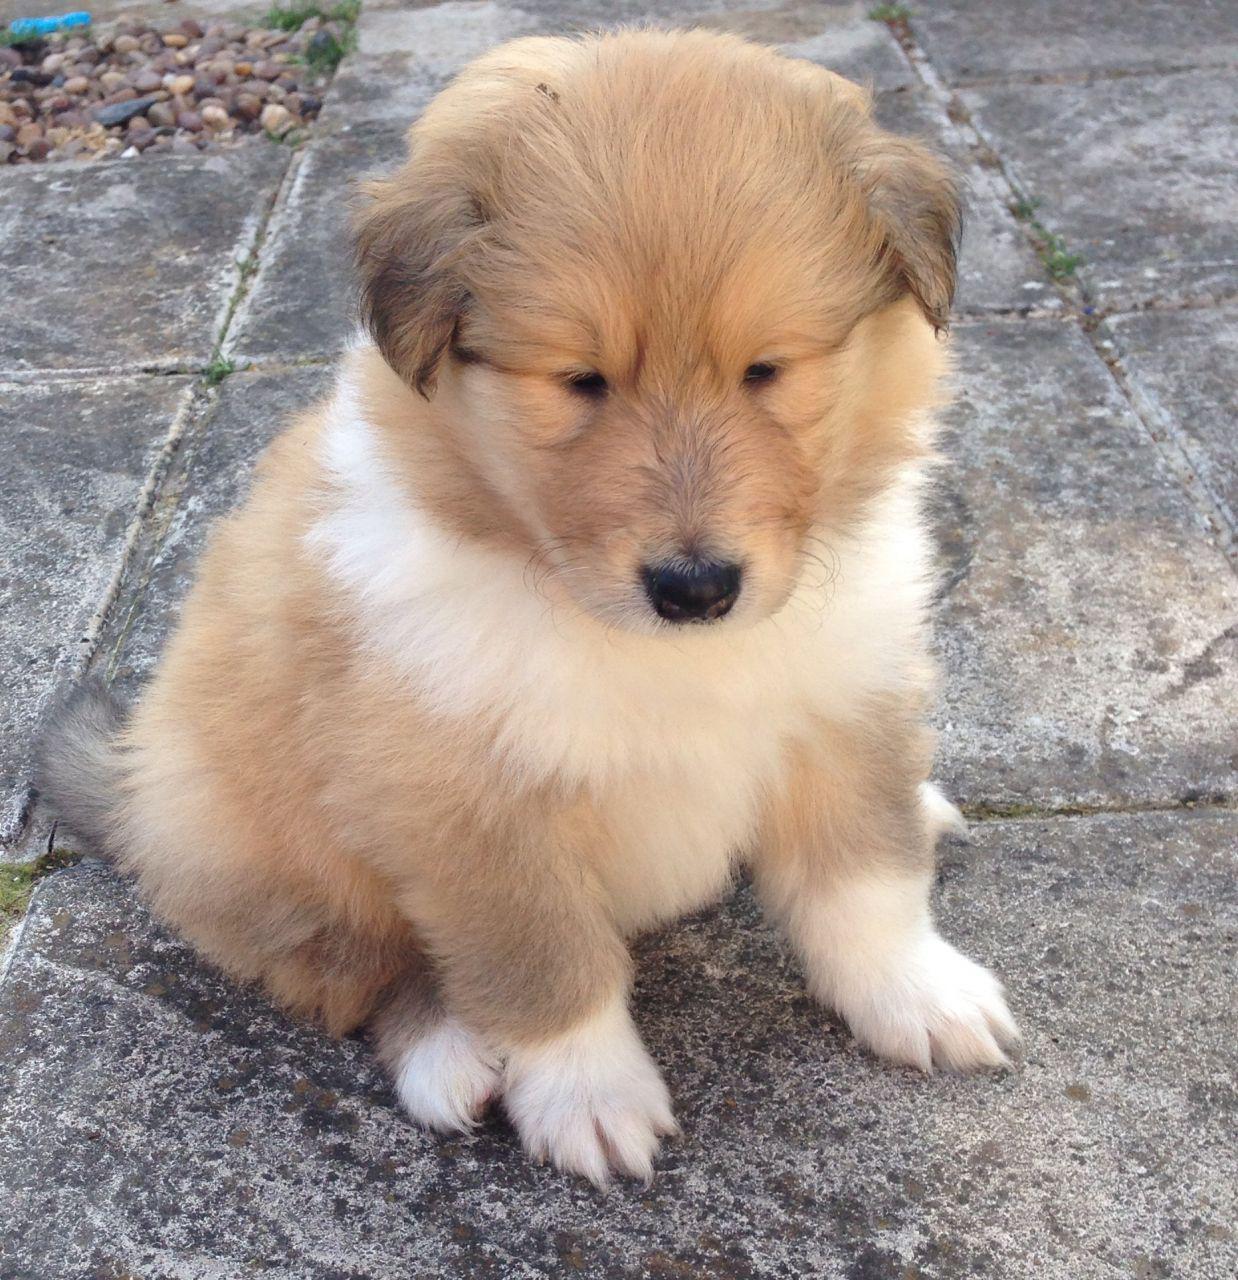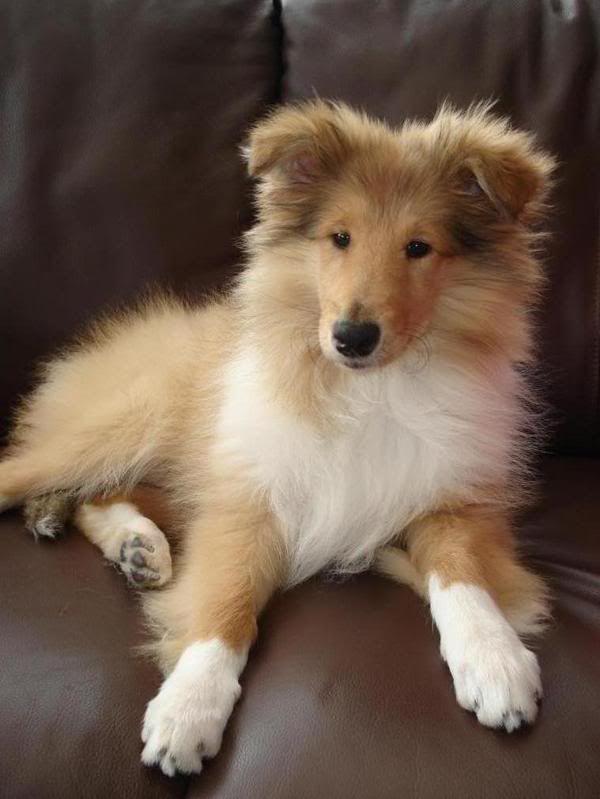The first image is the image on the left, the second image is the image on the right. Evaluate the accuracy of this statement regarding the images: "The right image contains exactly three dogs.". Is it true? Answer yes or no. No. 